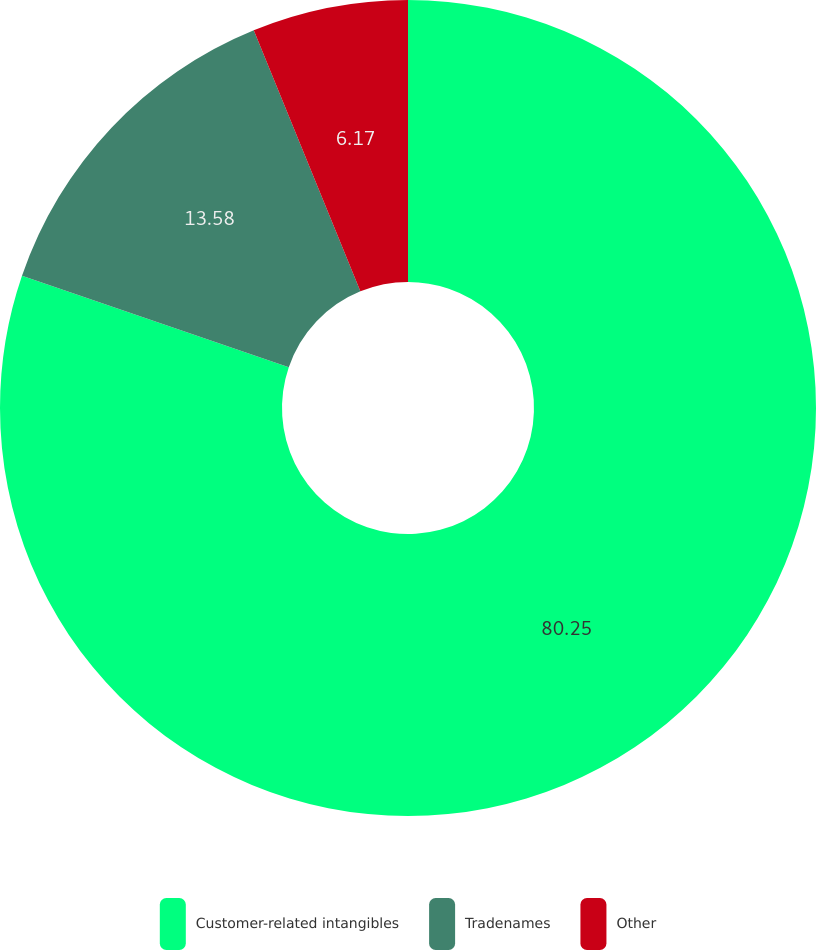Convert chart to OTSL. <chart><loc_0><loc_0><loc_500><loc_500><pie_chart><fcel>Customer-related intangibles<fcel>Tradenames<fcel>Other<nl><fcel>80.25%<fcel>13.58%<fcel>6.17%<nl></chart> 